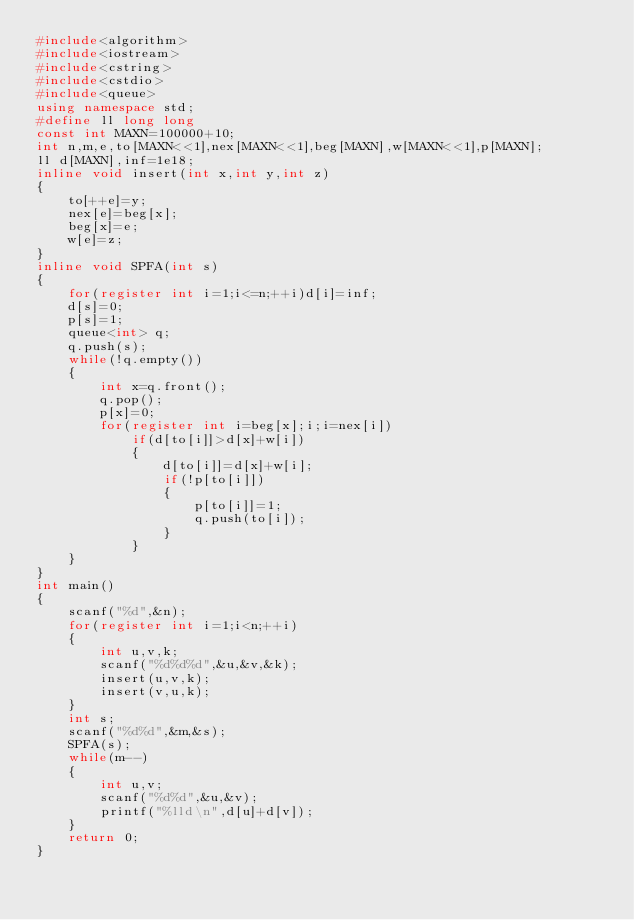<code> <loc_0><loc_0><loc_500><loc_500><_C++_>#include<algorithm>
#include<iostream>
#include<cstring>
#include<cstdio>
#include<queue>
using namespace std;
#define ll long long
const int MAXN=100000+10;
int n,m,e,to[MAXN<<1],nex[MAXN<<1],beg[MAXN],w[MAXN<<1],p[MAXN];
ll d[MAXN],inf=1e18;
inline void insert(int x,int y,int z)
{
	to[++e]=y;
	nex[e]=beg[x];
	beg[x]=e;
	w[e]=z;
}
inline void SPFA(int s)
{
	for(register int i=1;i<=n;++i)d[i]=inf;
	d[s]=0;
	p[s]=1;
	queue<int> q;
	q.push(s);
	while(!q.empty())
	{
		int x=q.front();
		q.pop();
		p[x]=0;
		for(register int i=beg[x];i;i=nex[i])
			if(d[to[i]]>d[x]+w[i])
			{
				d[to[i]]=d[x]+w[i];
				if(!p[to[i]])
				{
					p[to[i]]=1;
					q.push(to[i]);
				}
			}
	}
}
int main()
{
	scanf("%d",&n);
	for(register int i=1;i<n;++i)
	{
		int u,v,k;
		scanf("%d%d%d",&u,&v,&k);
		insert(u,v,k);
		insert(v,u,k);
	}
	int s;
	scanf("%d%d",&m,&s);
	SPFA(s);
	while(m--)
	{
		int u,v;
		scanf("%d%d",&u,&v);
		printf("%lld\n",d[u]+d[v]);
	}
	return 0;
}</code> 